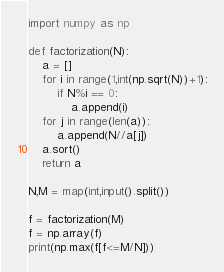<code> <loc_0><loc_0><loc_500><loc_500><_Python_>import numpy as np
 
def factorization(N):
    a = []
    for i in range(1,int(np.sqrt(N))+1):
        if N%i == 0:
            a.append(i)
    for j in range(len(a)):
        a.append(N//a[j])
    a.sort()
    return a
 
N,M = map(int,input().split())
 
f = factorization(M)
f = np.array(f)
print(np.max(f[f<=M/N]))</code> 